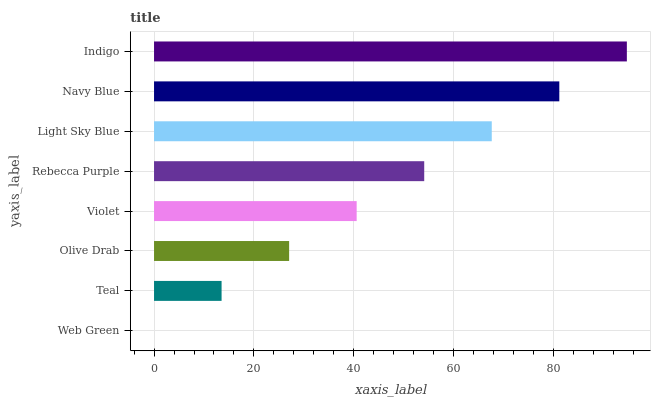Is Web Green the minimum?
Answer yes or no. Yes. Is Indigo the maximum?
Answer yes or no. Yes. Is Teal the minimum?
Answer yes or no. No. Is Teal the maximum?
Answer yes or no. No. Is Teal greater than Web Green?
Answer yes or no. Yes. Is Web Green less than Teal?
Answer yes or no. Yes. Is Web Green greater than Teal?
Answer yes or no. No. Is Teal less than Web Green?
Answer yes or no. No. Is Rebecca Purple the high median?
Answer yes or no. Yes. Is Violet the low median?
Answer yes or no. Yes. Is Indigo the high median?
Answer yes or no. No. Is Indigo the low median?
Answer yes or no. No. 